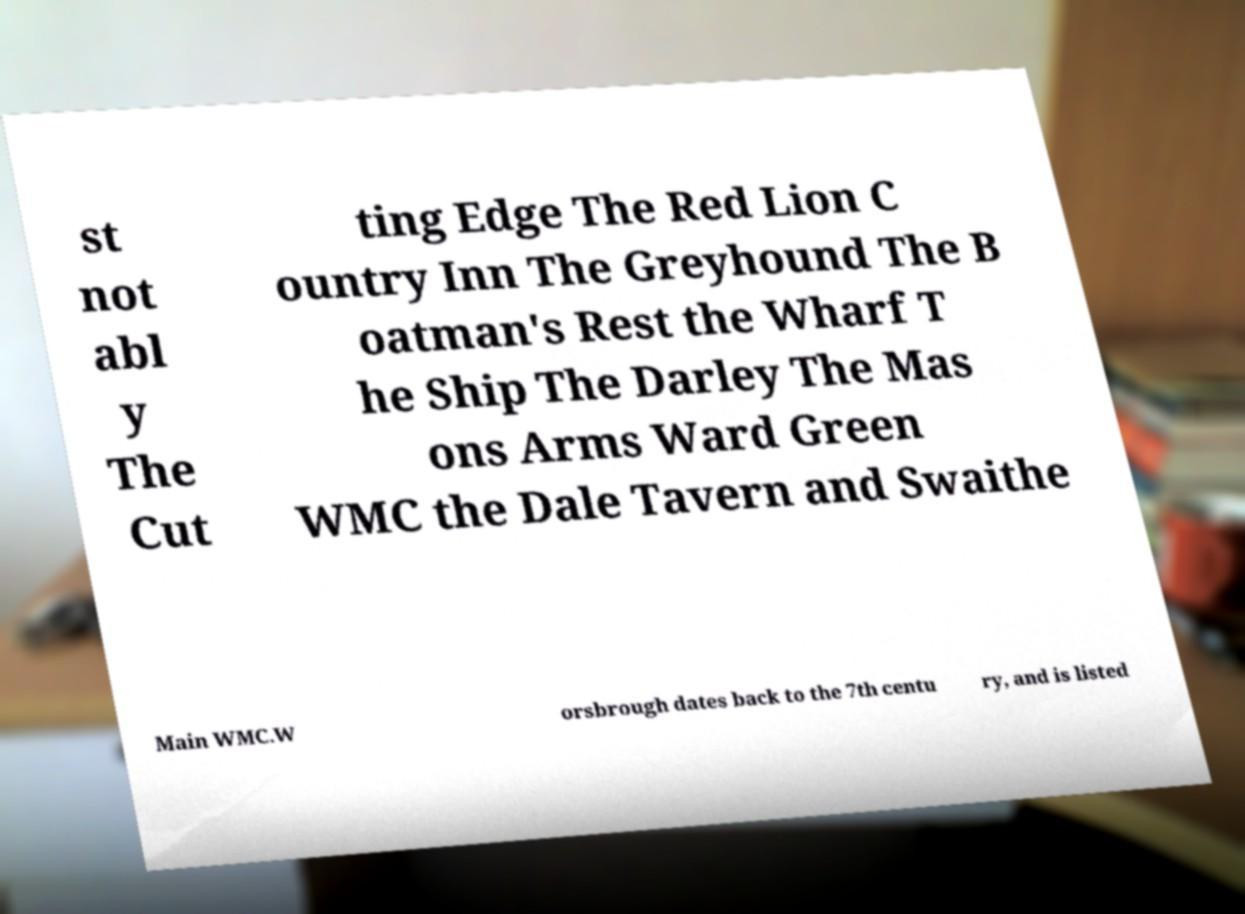I need the written content from this picture converted into text. Can you do that? st not abl y The Cut ting Edge The Red Lion C ountry Inn The Greyhound The B oatman's Rest the Wharf T he Ship The Darley The Mas ons Arms Ward Green WMC the Dale Tavern and Swaithe Main WMC.W orsbrough dates back to the 7th centu ry, and is listed 